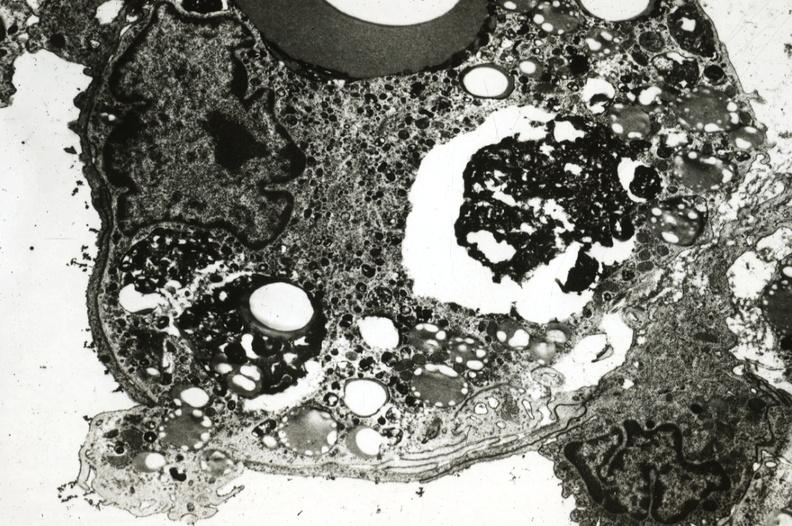what is present?
Answer the question using a single word or phrase. Aorta 